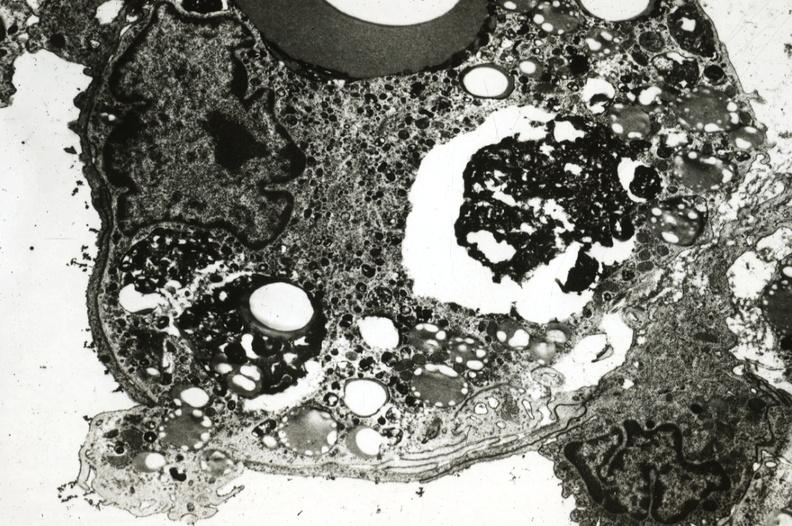what is present?
Answer the question using a single word or phrase. Aorta 